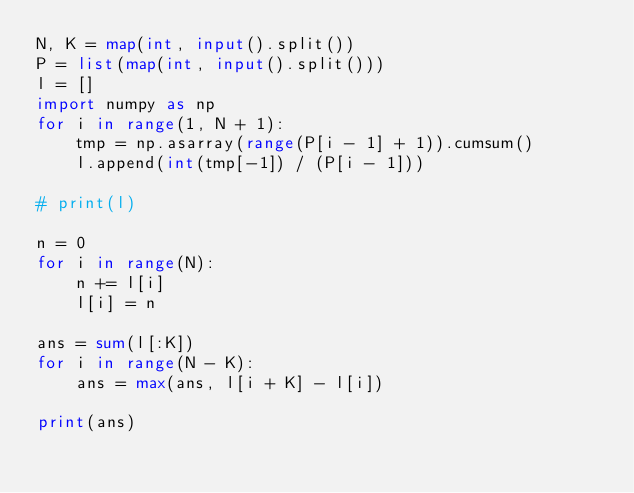Convert code to text. <code><loc_0><loc_0><loc_500><loc_500><_Python_>N, K = map(int, input().split())
P = list(map(int, input().split()))
l = []
import numpy as np
for i in range(1, N + 1):
    tmp = np.asarray(range(P[i - 1] + 1)).cumsum()
    l.append(int(tmp[-1]) / (P[i - 1]))

# print(l)

n = 0
for i in range(N):
    n += l[i]
    l[i] = n

ans = sum(l[:K])
for i in range(N - K):
    ans = max(ans, l[i + K] - l[i])

print(ans)
</code> 